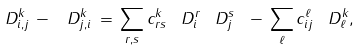<formula> <loc_0><loc_0><loc_500><loc_500>\ D _ { i , j } ^ { k } \, - \, \ D _ { j , i } ^ { k } \, = \, \sum _ { r , s } c ^ { k } _ { r s } \, \ D _ { i } ^ { r } \, \ D _ { j } ^ { s } \ - \, \sum _ { \ell } c _ { i j } ^ { \ell } \, \ D _ { \ell } ^ { k } ,</formula> 